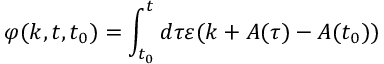<formula> <loc_0><loc_0><loc_500><loc_500>\varphi ( k , t , t _ { 0 } ) = \int _ { t _ { 0 } } ^ { t } d \tau \varepsilon ( k + A ( \tau ) - A ( t _ { 0 } ) )</formula> 